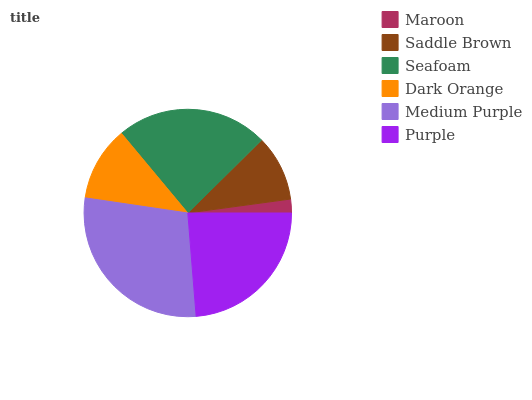Is Maroon the minimum?
Answer yes or no. Yes. Is Medium Purple the maximum?
Answer yes or no. Yes. Is Saddle Brown the minimum?
Answer yes or no. No. Is Saddle Brown the maximum?
Answer yes or no. No. Is Saddle Brown greater than Maroon?
Answer yes or no. Yes. Is Maroon less than Saddle Brown?
Answer yes or no. Yes. Is Maroon greater than Saddle Brown?
Answer yes or no. No. Is Saddle Brown less than Maroon?
Answer yes or no. No. Is Seafoam the high median?
Answer yes or no. Yes. Is Dark Orange the low median?
Answer yes or no. Yes. Is Medium Purple the high median?
Answer yes or no. No. Is Medium Purple the low median?
Answer yes or no. No. 